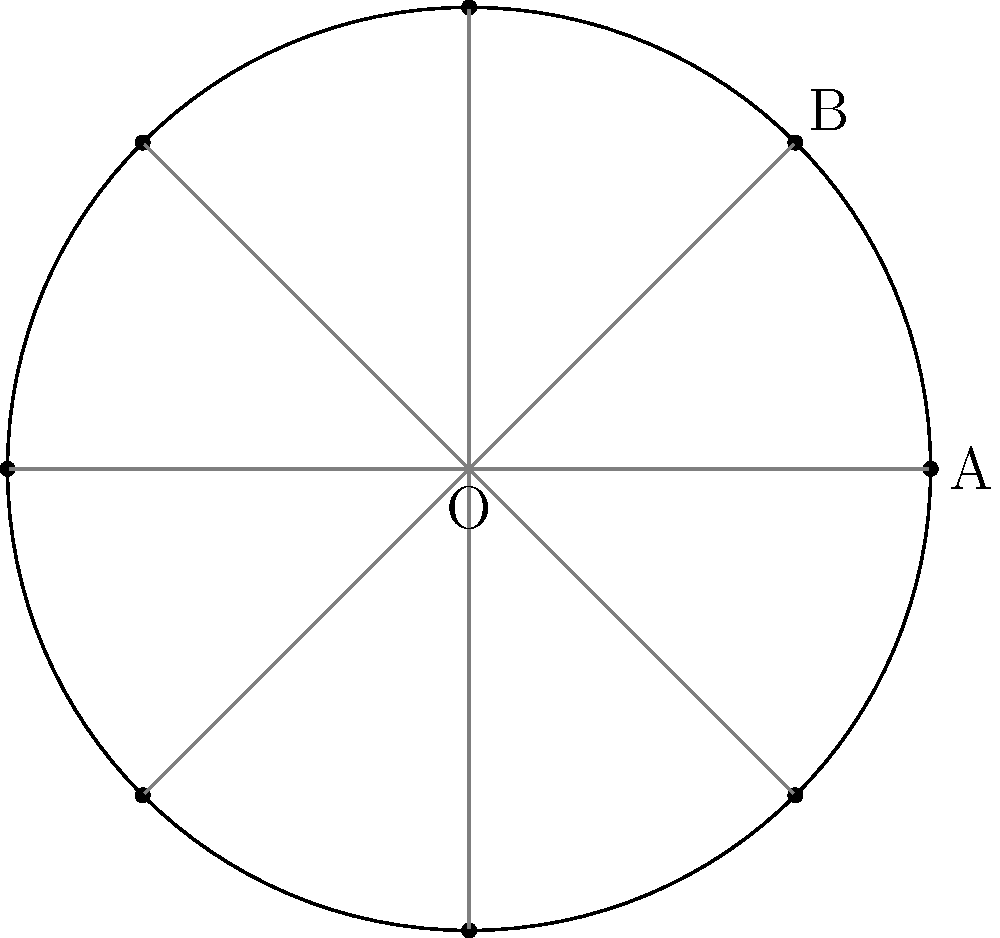For the Diwali festival, you're arranging 8 diyas in a perfect circle. If the angle between two adjacent diyas at the center of the circle is $x°$, what is the value of $x$? Let's approach this step-by-step:

1) In a circle, there are 360° in total.

2) The diyas are evenly spaced around the circle, forming 8 equal central angles.

3) To find the angle between two adjacent diyas, we need to divide the total degrees in a circle by the number of diyas:

   $$x = \frac{360°}{8}$$

4) Simplifying:
   
   $$x = 45°$$

Therefore, the angle between two adjacent diyas at the center of the circle is 45°.
Answer: 45° 